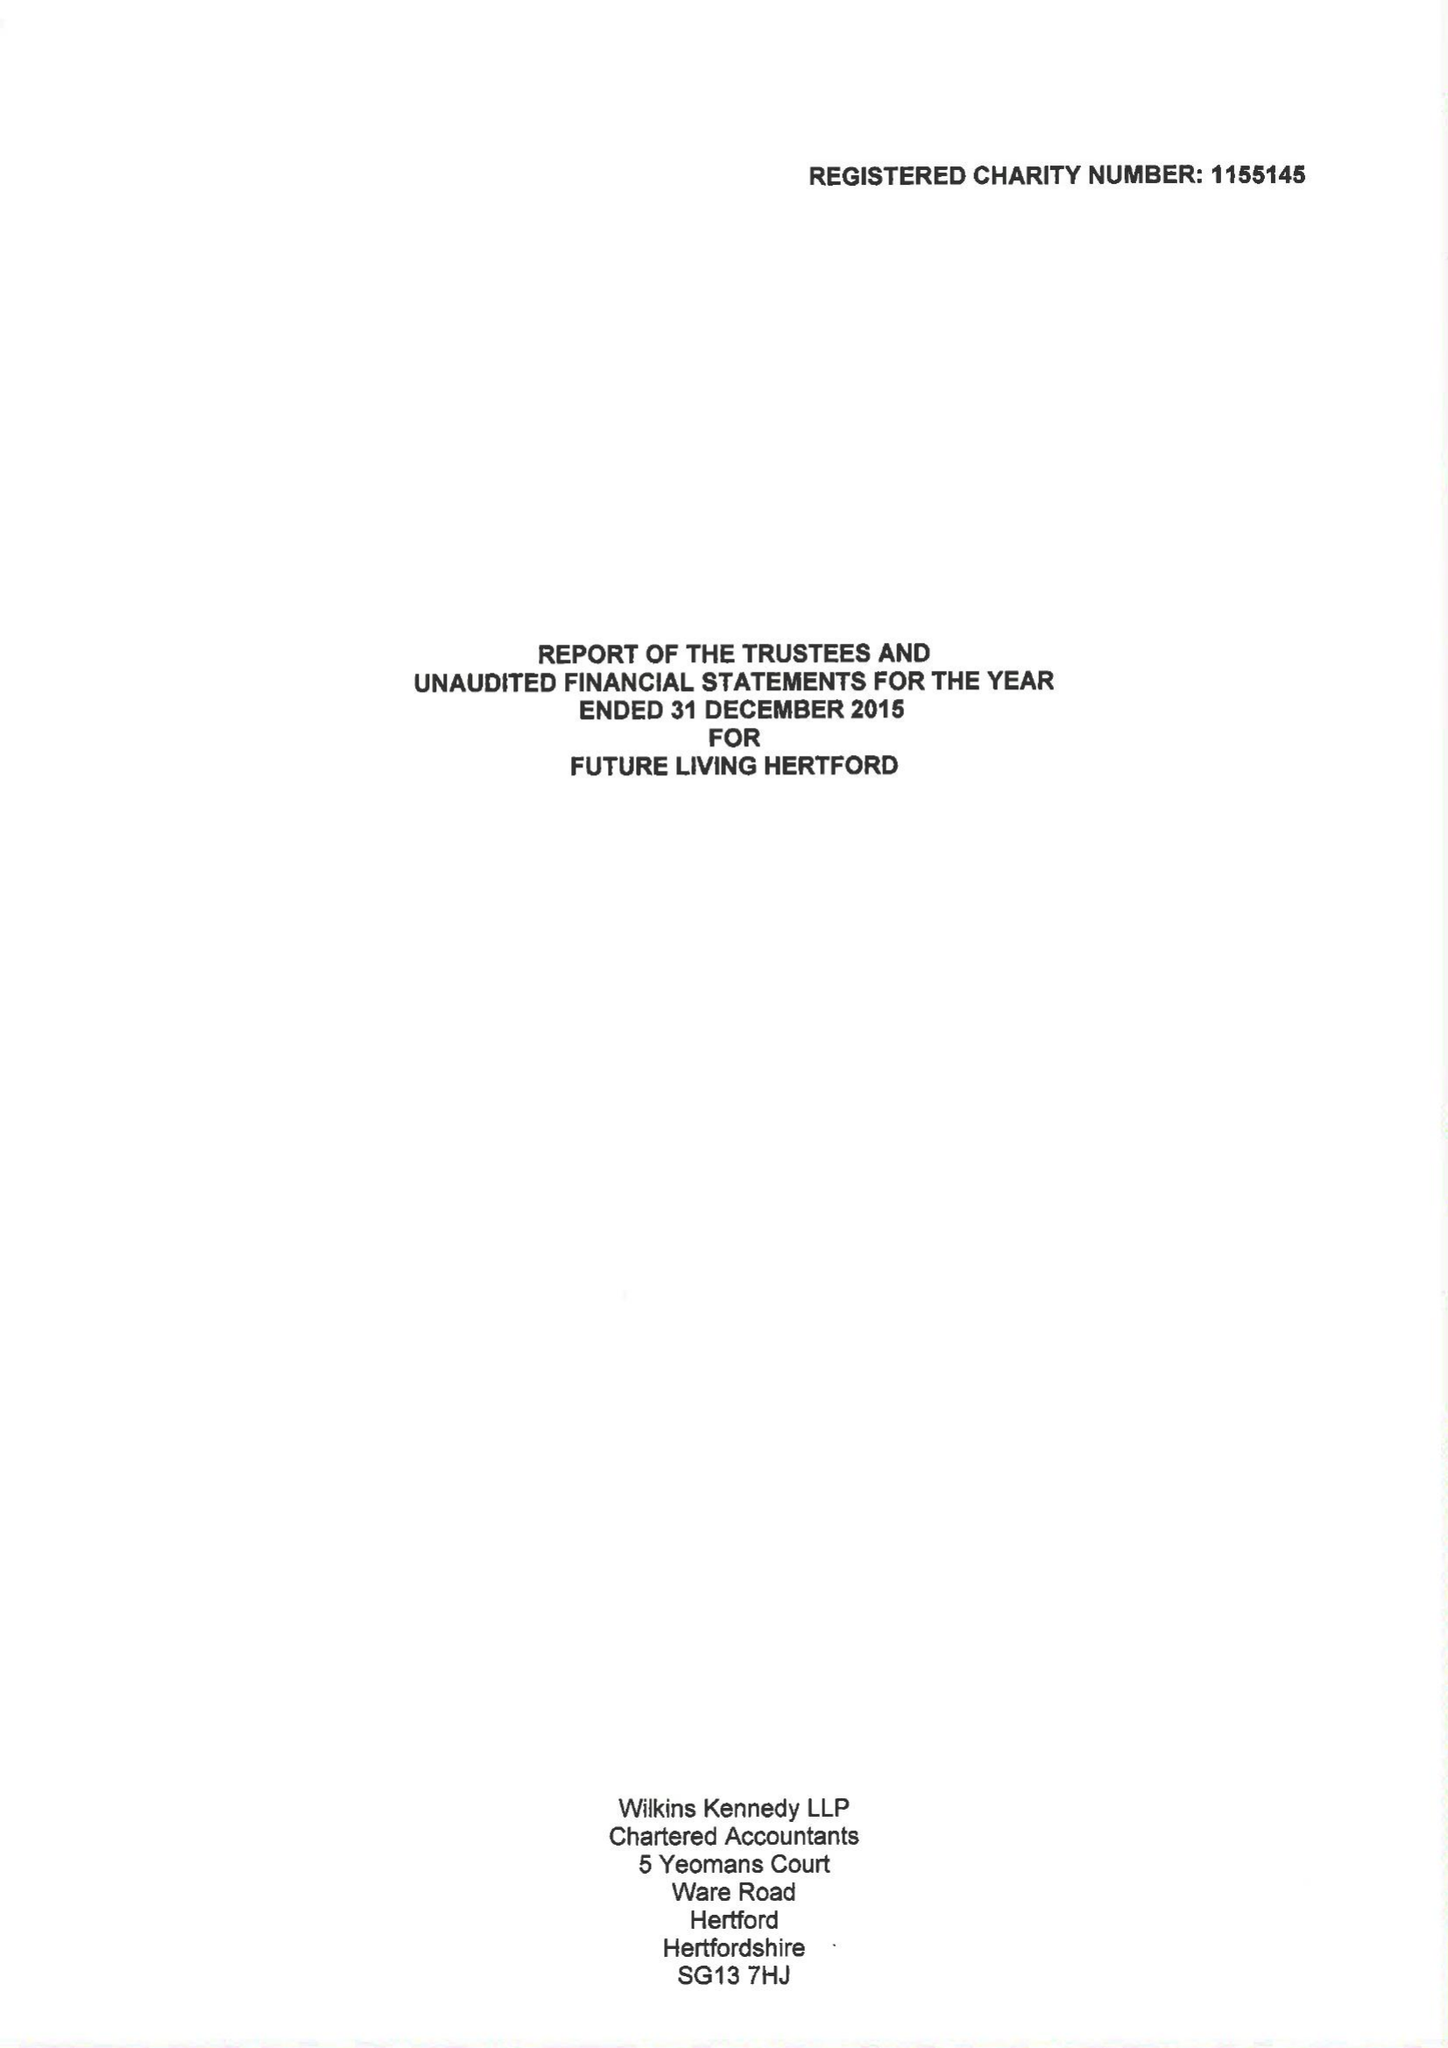What is the value for the address__post_town?
Answer the question using a single word or phrase. HERTFORD 